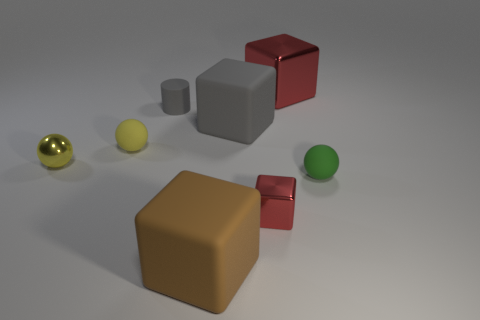Do the small cylinder and the metal ball have the same color?
Provide a short and direct response. No. What number of tiny rubber spheres are the same color as the tiny cylinder?
Give a very brief answer. 0. There is a rubber object on the right side of the block behind the big gray rubber cube; how big is it?
Ensure brevity in your answer.  Small. What shape is the green object?
Offer a very short reply. Sphere. What material is the tiny object that is in front of the green matte object?
Keep it short and to the point. Metal. What color is the small sphere that is on the right side of the shiny object that is behind the matte sphere that is left of the tiny gray matte cylinder?
Offer a very short reply. Green. What color is the shiny ball that is the same size as the green thing?
Your answer should be very brief. Yellow. How many metallic objects are small green things or big brown blocks?
Provide a succinct answer. 0. What is the color of the sphere that is made of the same material as the green thing?
Your response must be concise. Yellow. There is a small thing that is in front of the tiny sphere right of the tiny gray rubber cylinder; what is its material?
Your answer should be very brief. Metal. 